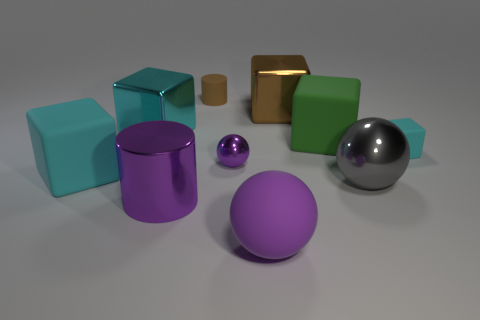Subtract all brown balls. How many cyan blocks are left? 3 Subtract 1 spheres. How many spheres are left? 2 Subtract all green rubber blocks. How many blocks are left? 4 Subtract all green cubes. How many cubes are left? 4 Subtract all yellow cubes. Subtract all green cylinders. How many cubes are left? 5 Subtract all balls. How many objects are left? 7 Subtract all brown cubes. Subtract all cyan matte cubes. How many objects are left? 7 Add 5 purple shiny cylinders. How many purple shiny cylinders are left? 6 Add 1 brown cylinders. How many brown cylinders exist? 2 Subtract 1 purple cylinders. How many objects are left? 9 